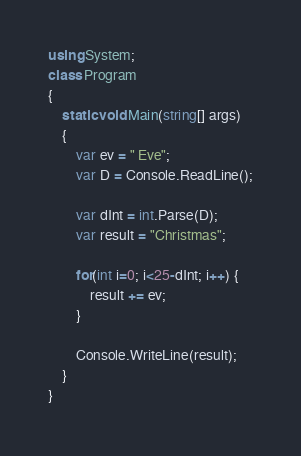Convert code to text. <code><loc_0><loc_0><loc_500><loc_500><_C#_>using System;
class Program
{
    static void Main(string[] args)
    {
        var ev = " Eve";
        var D = Console.ReadLine();
        
        var dInt = int.Parse(D);
        var result = "Christmas";
        
        for(int i=0; i<25-dInt; i++) {
            result += ev;
        }
        
        Console.WriteLine(result);
    }
}</code> 